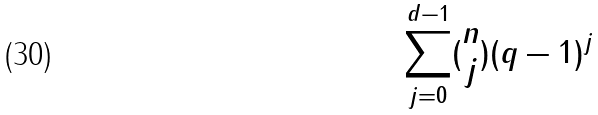<formula> <loc_0><loc_0><loc_500><loc_500>\sum _ { j = 0 } ^ { d - 1 } ( \begin{matrix} n \\ j \end{matrix} ) ( q - 1 ) ^ { j }</formula> 